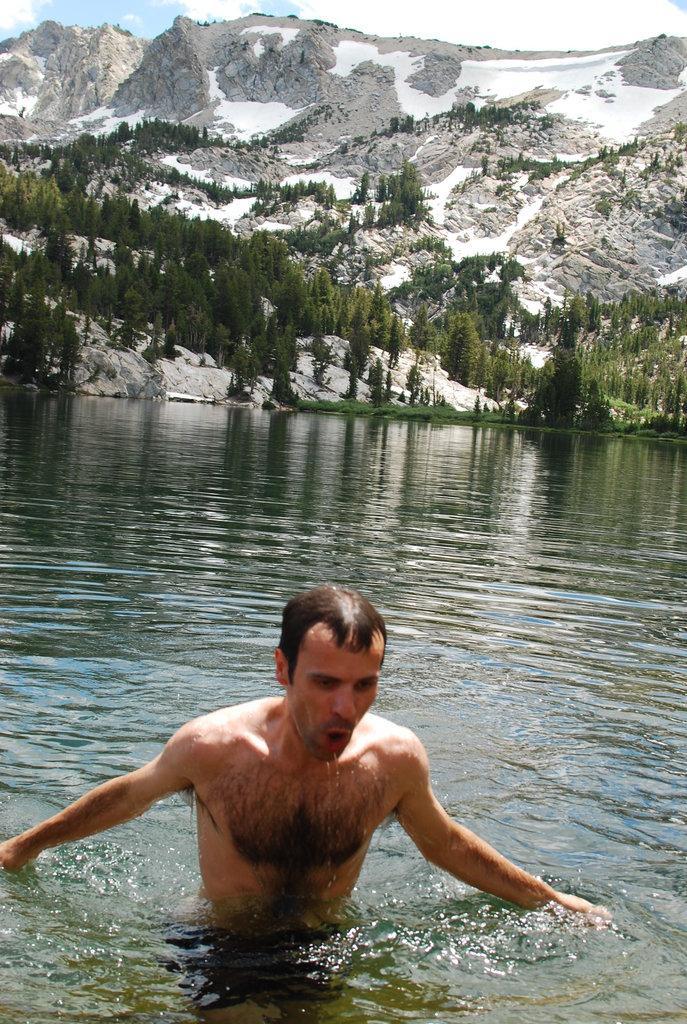How would you summarize this image in a sentence or two? In the middle of the image we can see a man in the water, in the background we can see few trees and hills. 